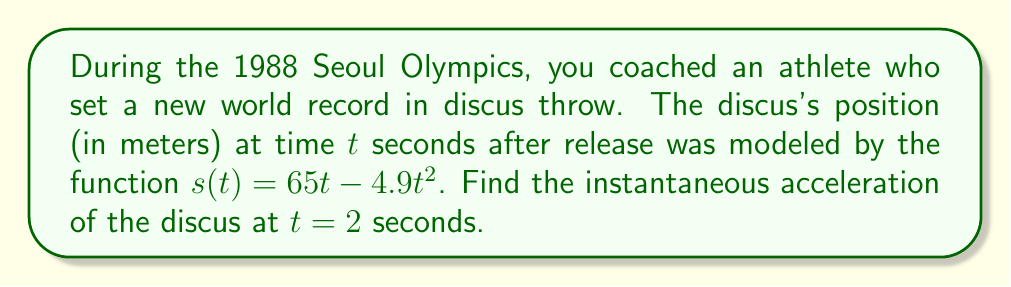Could you help me with this problem? To find the instantaneous acceleration, we need to take the second derivative of the position function.

Step 1: Find the velocity function (first derivative)
The velocity function $v(t)$ is the first derivative of the position function $s(t)$.
$$v(t) = s'(t) = \frac{d}{dt}(65t - 4.9t^2) = 65 - 9.8t$$

Step 2: Find the acceleration function (second derivative)
The acceleration function $a(t)$ is the derivative of the velocity function $v(t)$.
$$a(t) = v'(t) = \frac{d}{dt}(65 - 9.8t) = -9.8$$

Step 3: Evaluate the acceleration at $t = 2$ seconds
Since the acceleration function is constant, the instantaneous acceleration at any time, including $t = 2$, is:
$$a(2) = -9.8 \text{ m/s}^2$$

This result shows that the discus experiences a constant acceleration due to gravity, which is approximately $-9.8 \text{ m/s}^2$ on Earth.
Answer: $-9.8 \text{ m/s}^2$ 